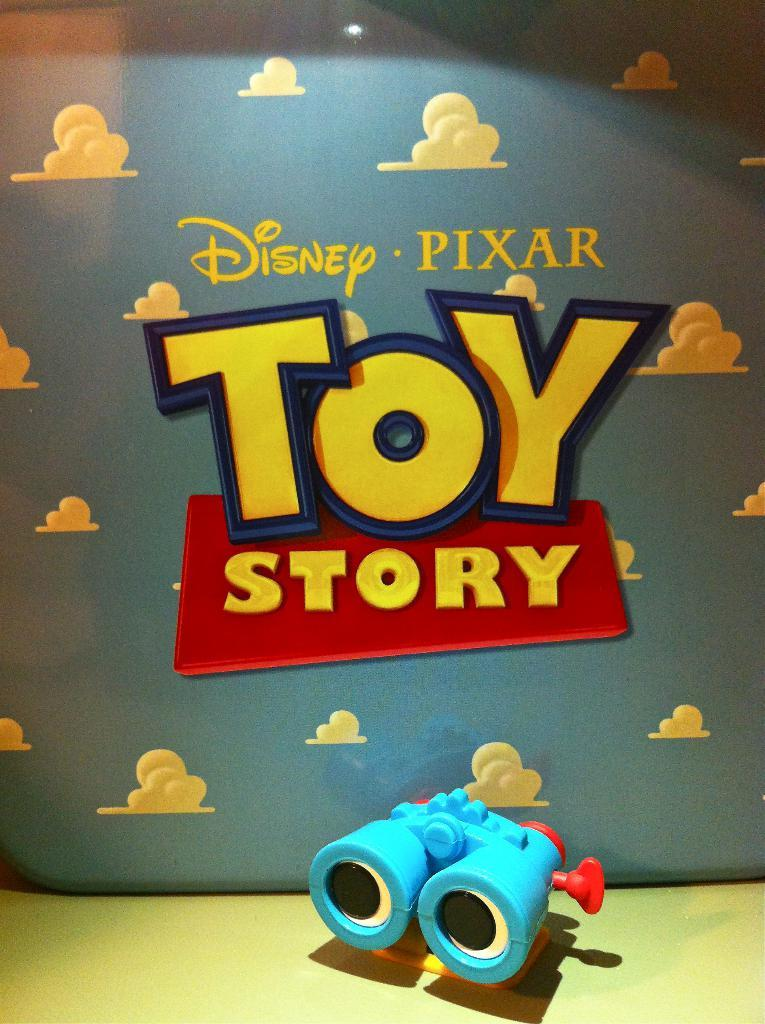<image>
Give a short and clear explanation of the subsequent image. binoculars toy in front of sign for disney pixar toy story 